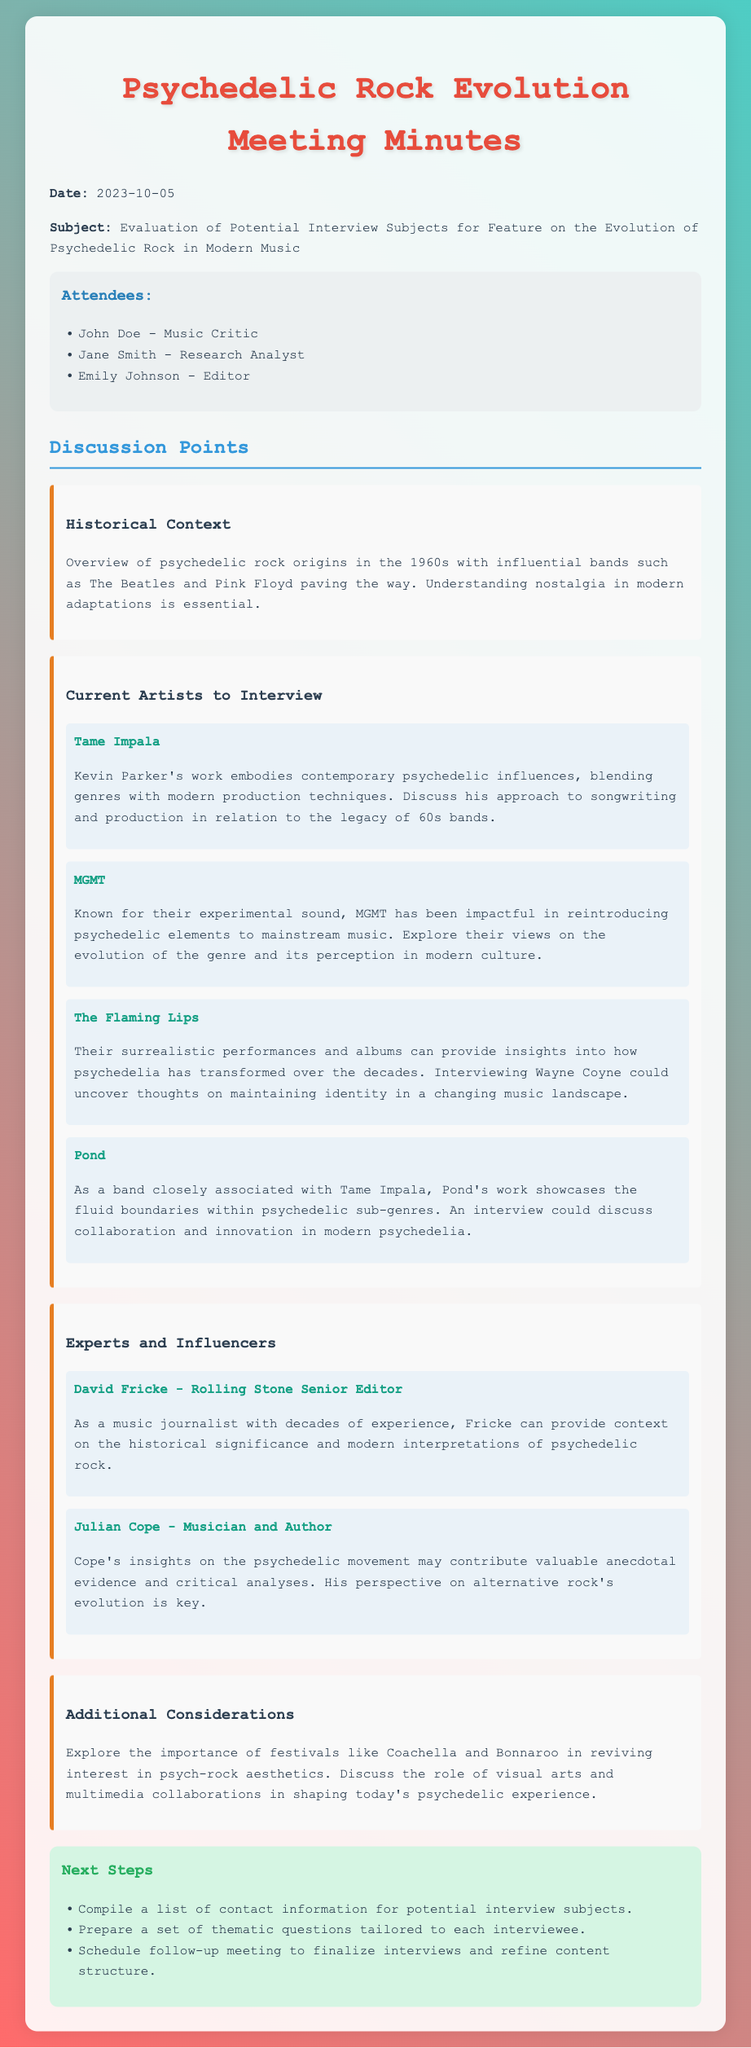What is the date of the meeting? The date of the meeting is specified in the document as 2023-10-05.
Answer: 2023-10-05 Who is the music critic in attendance? The document lists John Doe as the music critic who attended the meeting.
Answer: John Doe Name one current artist being considered for an interview. The current artists under consideration for interviews are outlined in the document with specific names.
Answer: Tame Impala What role does David Fricke hold? The document describes David Fricke as a Senior Editor for Rolling Stone.
Answer: Rolling Stone Senior Editor What aspect of psychedelic rock is emphasized in the historical context? The historical context section mentions how influential bands like The Beatles and Pink Floyd have paved the way for psychedelic rock origins.
Answer: Influential bands Who is suggested for insight on the evolution of alternative rock? The document highlights Julian Cope as a musician and author whose insights may be valuable for understanding the evolution of alternative rock.
Answer: Julian Cope What is one of the next steps outlined in the meeting? The document lists compiling contact information for potential interview subjects as one of the next steps.
Answer: Compile a list of contact information What festivals are mentioned as important in reviving interest in psych-rock aesthetics? The document references festivals like Coachella and Bonnaroo for their role in reviving psychedelic rock aesthetics.
Answer: Coachella and Bonnaroo What is the purpose of the interviews being planned? The interviews aim to explore the evolution of psychedelic rock in modern music through various perspectives.
Answer: Explore the evolution of psychedelic rock 